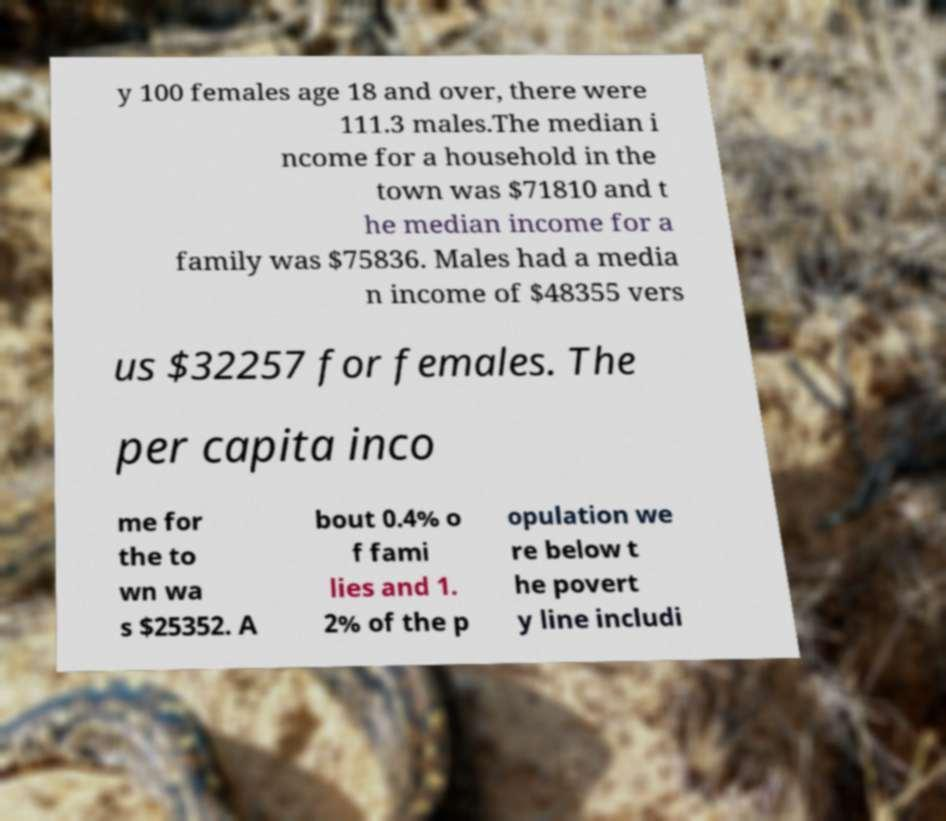Please identify and transcribe the text found in this image. y 100 females age 18 and over, there were 111.3 males.The median i ncome for a household in the town was $71810 and t he median income for a family was $75836. Males had a media n income of $48355 vers us $32257 for females. The per capita inco me for the to wn wa s $25352. A bout 0.4% o f fami lies and 1. 2% of the p opulation we re below t he povert y line includi 